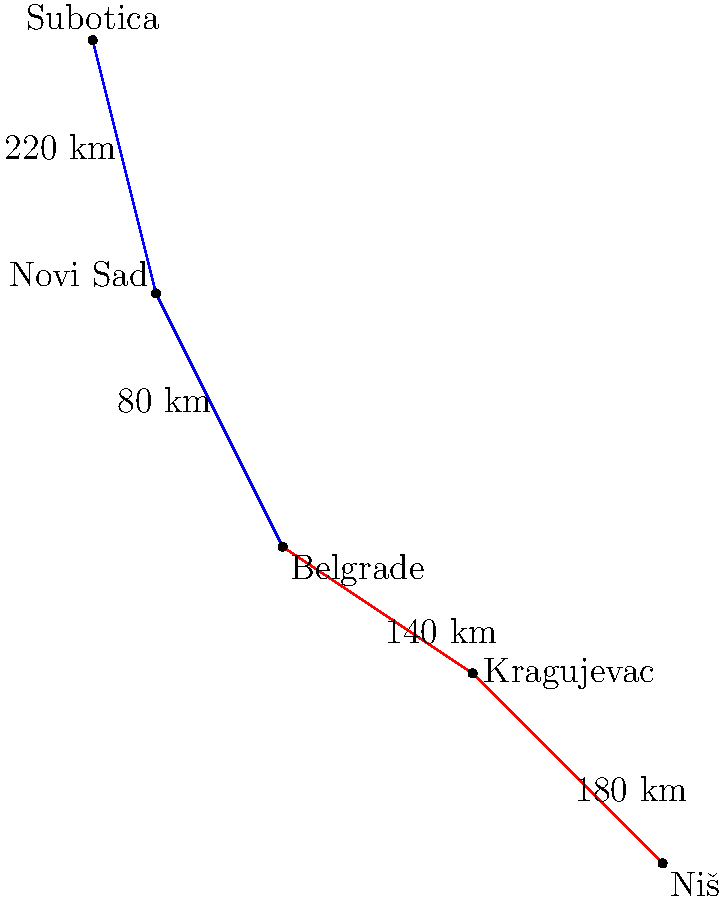Based on the schematic road map of Serbia, what is the total distance from Subotica to Niš when traveling through Belgrade? To find the total distance from Subotica to Niš through Belgrade, we need to add up the distances of each segment of the journey:

1. Subotica to Novi Sad: 220 km
2. Novi Sad to Belgrade: 80 km
3. Belgrade to Kragujevac: 140 km
4. Kragujevac to Niš: 180 km

Let's add these distances:

$$ 220 + 80 + 140 + 180 = 620 $$

Therefore, the total distance from Subotica to Niš when traveling through Belgrade is 620 km.
Answer: 620 km 